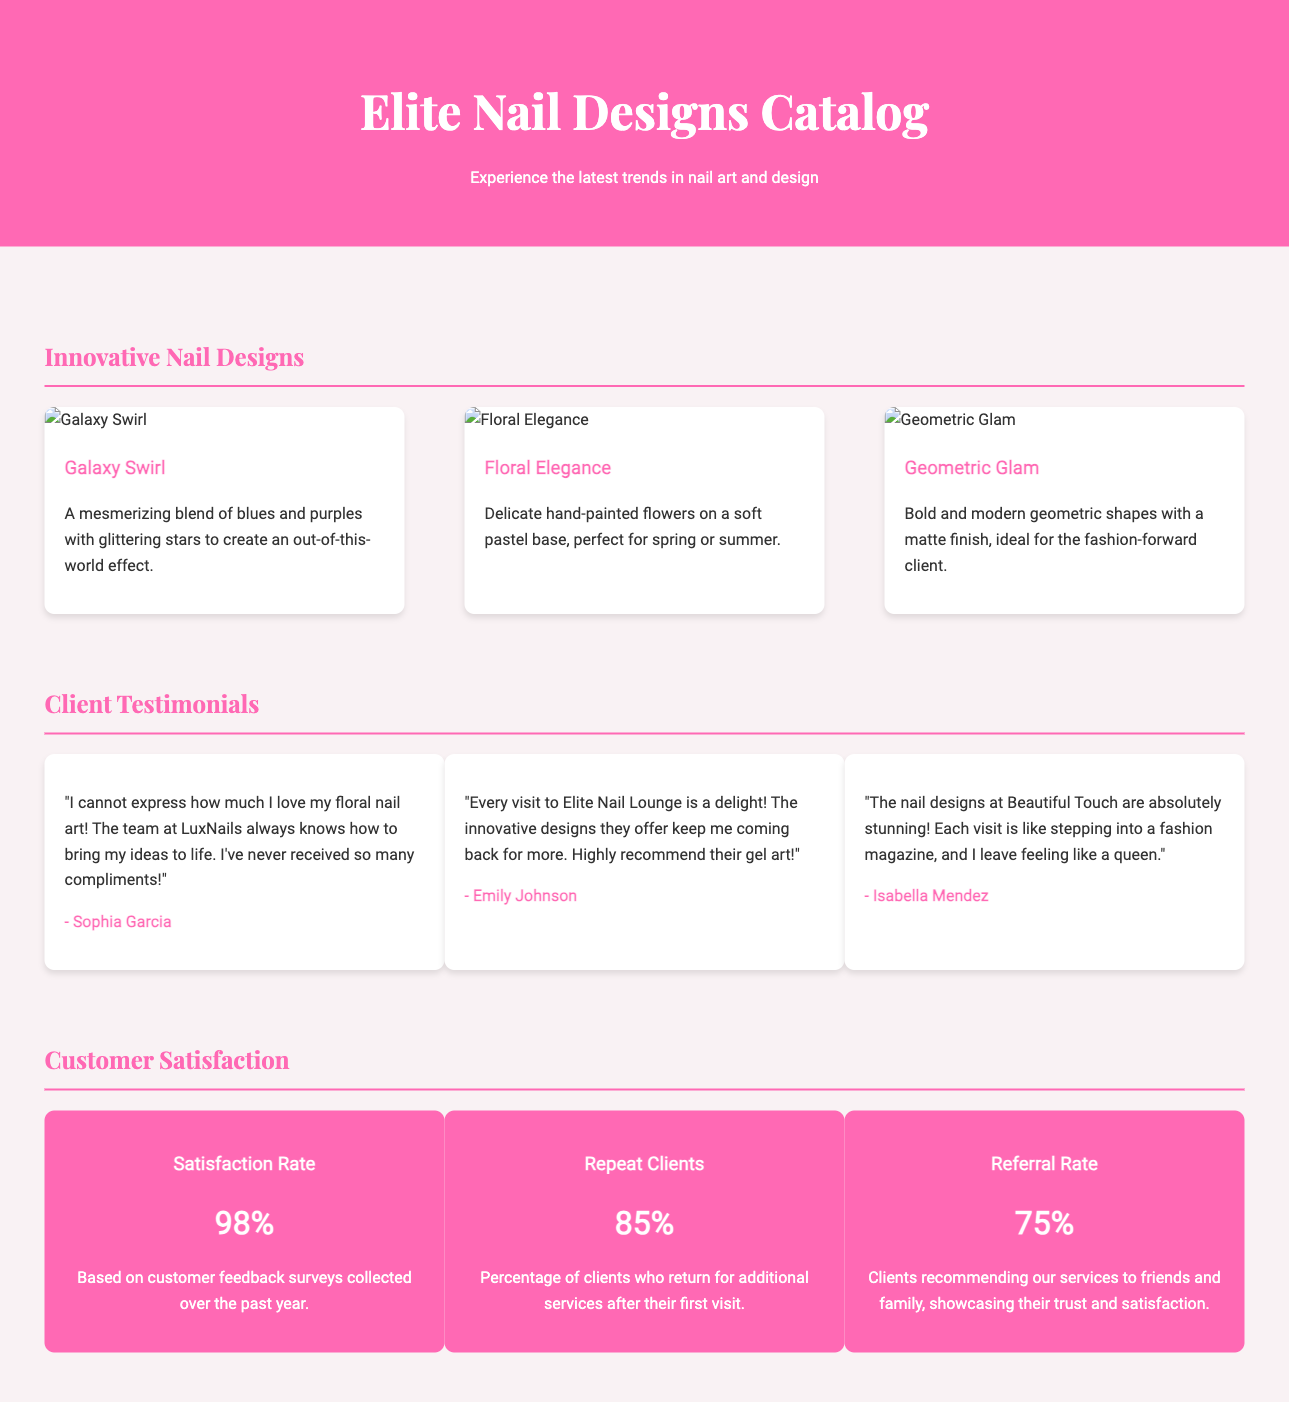What is the name of the first nail design showcased? The first nail design in the catalog is "Galaxy Swirl," which is mentioned at the top of the designs section.
Answer: Galaxy Swirl What percentage of clients are repeat clients? The document states that 85% of clients return for additional services after their first visit.
Answer: 85% What is the satisfaction rate according to the customer feedback surveys? The satisfaction rate is specifically mentioned as 98% based on the customer feedback collected over the past year.
Answer: 98% Who is the client that praised the floral nail art? The testimonial section includes a quote from Sophia Garcia, who expressed her love for the floral nail art.
Answer: Sophia Garcia Which design is described as perfect for spring or summer? The "Floral Elegance" design is described as delicate hand-painted flowers on a soft pastel base, making it ideal for spring or summer.
Answer: Floral Elegance How many testimonial cards are featured in the document? The document includes three testimonial cards featuring different client feedback.
Answer: Three What is the referral rate stated in the satisfaction section? The document indicates that the referral rate is 75%, showing how many clients recommend the services to friends and family.
Answer: 75% What is the main color theme of the header? The header's background color is a vibrant pink shade, specifically #ff69b4.
Answer: Pink What nail design is depicted with bold geometric shapes? The "Geometric Glam" design features bold and modern geometric shapes.
Answer: Geometric Glam 